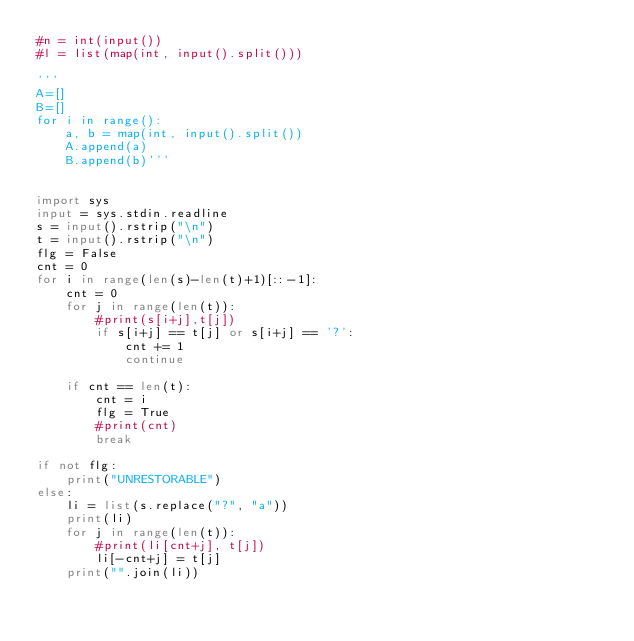<code> <loc_0><loc_0><loc_500><loc_500><_Python_>#n = int(input())
#l = list(map(int, input().split()))

'''
A=[]
B=[]
for i in range():
    a, b = map(int, input().split())
    A.append(a)
    B.append(b)'''


import sys
input = sys.stdin.readline
s = input().rstrip("\n")
t = input().rstrip("\n")
flg = False
cnt = 0
for i in range(len(s)-len(t)+1)[::-1]:
    cnt = 0
    for j in range(len(t)):
        #print(s[i+j],t[j])
        if s[i+j] == t[j] or s[i+j] == '?':
            cnt += 1
            continue

    if cnt == len(t):
        cnt = i
        flg = True
        #print(cnt)
        break

if not flg:
    print("UNRESTORABLE")
else:
    li = list(s.replace("?", "a"))
    print(li)
    for j in range(len(t)):
        #print(li[cnt+j], t[j])
        li[-cnt+j] = t[j]
    print("".join(li))
</code> 